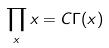Convert formula to latex. <formula><loc_0><loc_0><loc_500><loc_500>\prod _ { x } x = C \Gamma ( x )</formula> 